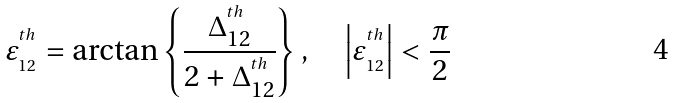<formula> <loc_0><loc_0><loc_500><loc_500>\varepsilon ^ { ^ { t h } } _ { _ { 1 2 } } = \arctan \left \{ \frac { \Delta _ { 1 2 } ^ { ^ { t h } } } { 2 + \Delta _ { 1 2 } ^ { ^ { t h } } } \right \} , \quad \left | \varepsilon ^ { ^ { t h } } _ { _ { 1 2 } } \right | < \frac { \pi } { 2 }</formula> 